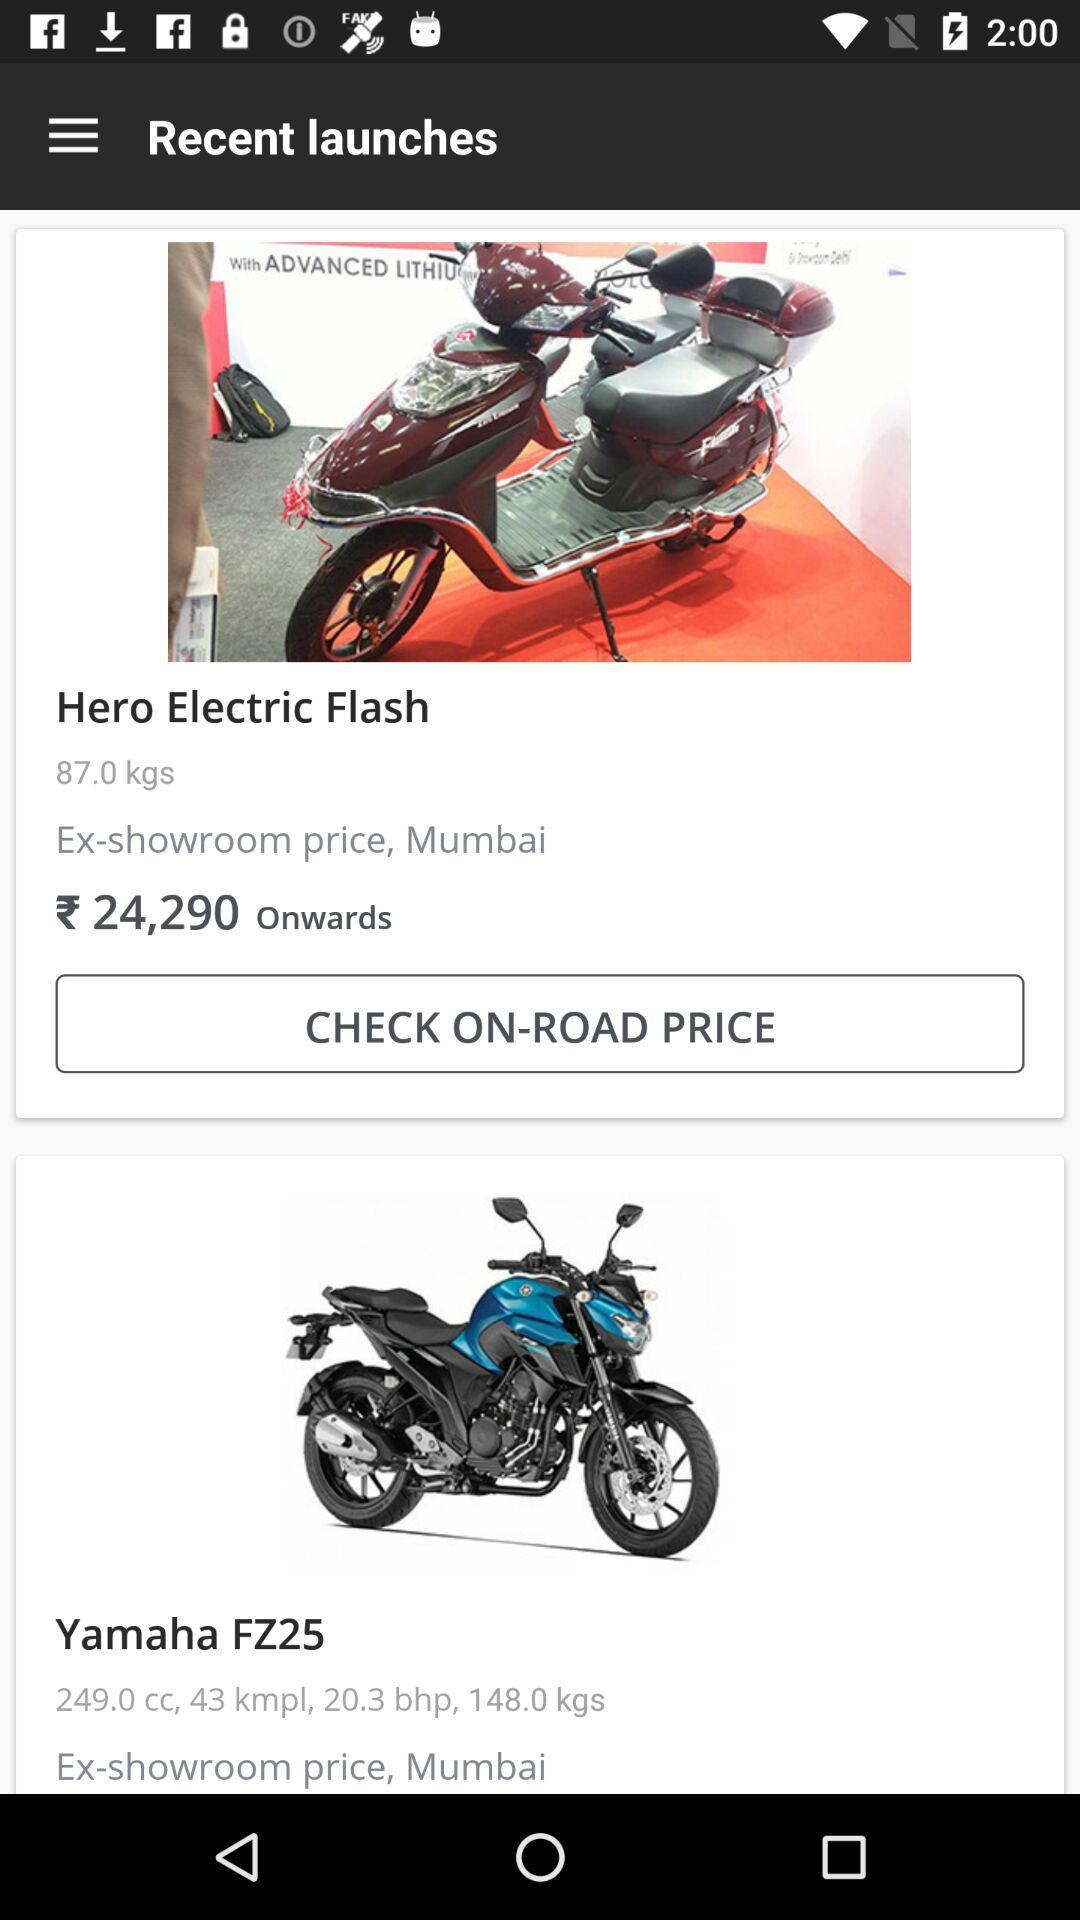What is the weight of the "Yamaha FZ25"? The weight of the "Yamaha FZ25" is 148 kg. 